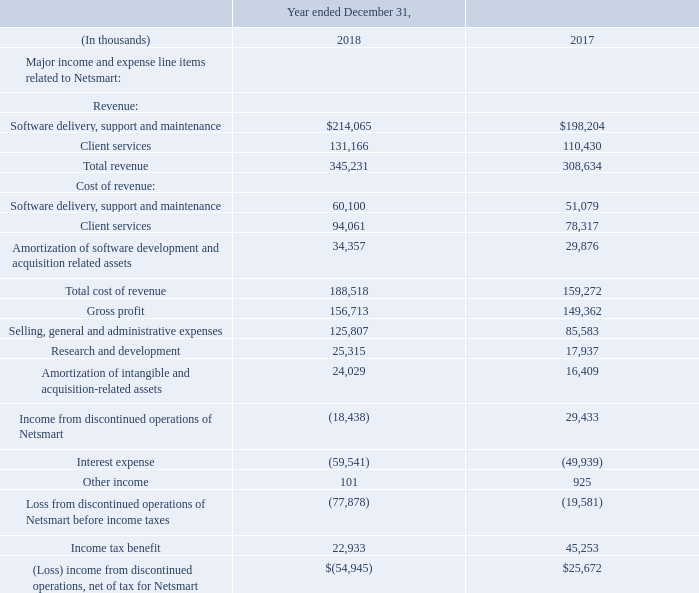Netsmart Discontinued Operation
On December 31, 2018, we sold all of the Class A Common Units of Netsmart held by the Company in exchange for $566.6 million in cash plus a final settlement as determined following the closing.
Prior to the sale, Netsmart comprised a separate reportable segment, which due to its significance to our historical consolidated financial statements and results of operations, is reported as a discontinued operation as a result of the sale. Refer to Note 4, “Business Combinations and Other Investments” for additional information about this transaction.
The following table summarizes Netsmart’s major income and expense line items as reported in the consolidated statements of operations for the years ended December 31, 2018 and 2017:
(1) Activity includes both Netsmart and intercompany transactions that would not have been eliminated if Netsmart’s results were not consolidated.
What was the exchange amount in cash for the Class A Common Units of Netsmart? $566.6 million. What was the Total revenue in 2018?
Answer scale should be: thousand. 345,231. What was the Client services revenue in 2018?
Answer scale should be: thousand. 131,166. What is the change in the Client services revenue from 2017 to 2018?
Answer scale should be: thousand. 131,166 - 110,430
Answer: 20736. What is the average Total cost of revenue for 2017-2018?
Answer scale should be: thousand. (345,231 + 308,634) / 2
Answer: 326932.5. What is the percentage change in the Gross profit from 2017 to 2018?
Answer scale should be: percent. 156,713 / 149,362 - 1
Answer: 4.92. 